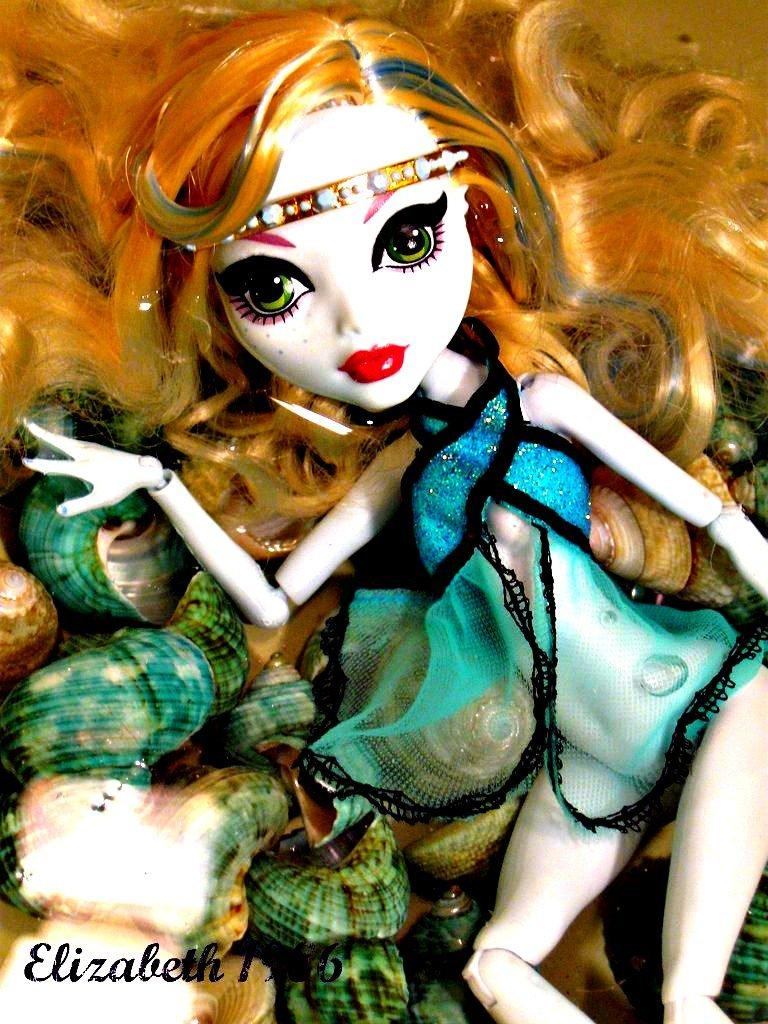What type of image is depicted in the middle of the scene? The image appears to be an animated image in the middle. Can you describe any objects or features in the background of the image? There are objects in the background that resemble shells. How many women are sitting on the throne in the image? There is no throne or women present in the image; it features an animated image and shell-like objects in the background. 